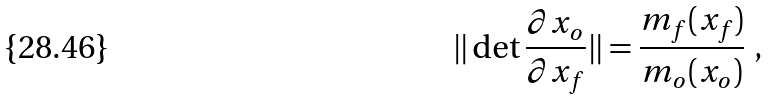<formula> <loc_0><loc_0><loc_500><loc_500>\| \det \frac { \partial x _ { o } } { \partial x _ { f } } \| = \frac { m _ { f } ( x _ { f } ) } { m _ { o } ( x _ { o } ) } \ ,</formula> 